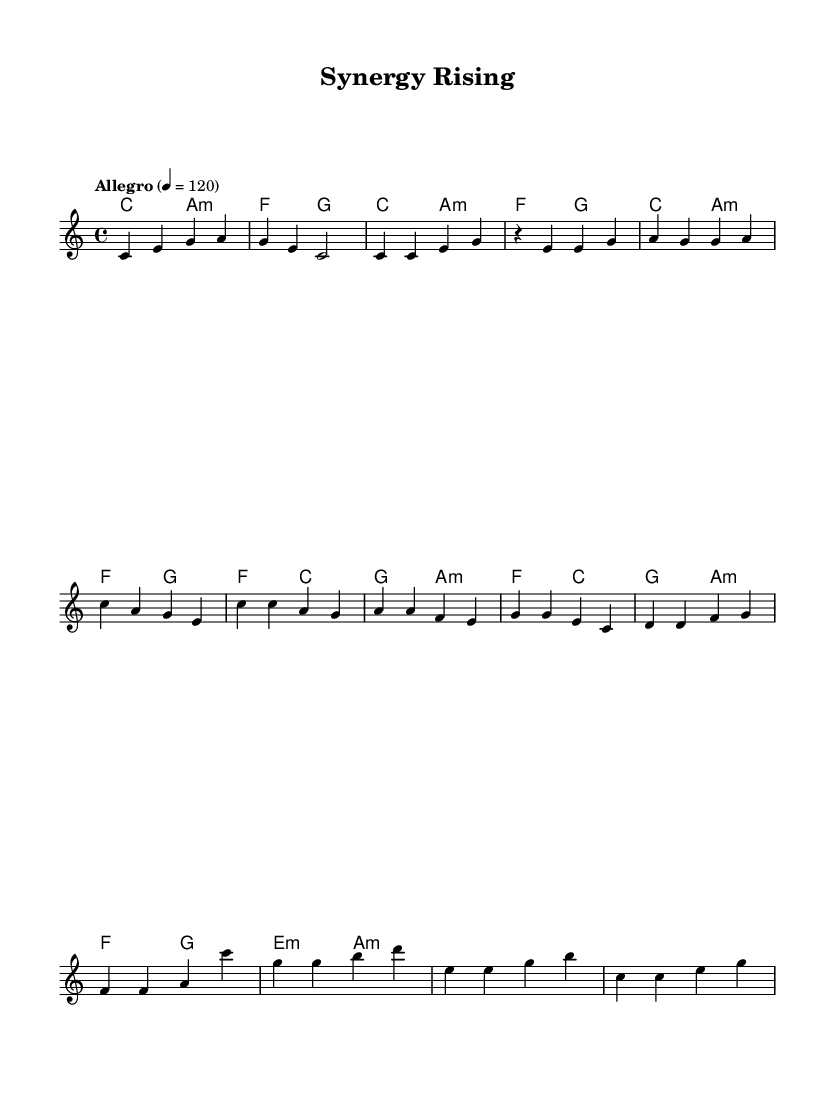What is the key signature of this music? The key signature indicated in the music is C major, which has no sharps or flats. It can be identified by looking at the beginning of the staff where the key signature is notated.
Answer: C major What is the time signature of this music? The time signature is 4/4, indicated at the beginning of the score. This means there are four beats in each measure and the quarter note receives one beat.
Answer: 4/4 What is the tempo marking of this piece? The tempo of the music is marked as "Allegro" at a speed of 120 beats per minute, which suggests a brisk pace and energy. This marking is found at the start of the piece.
Answer: Allegro 4 = 120 How many measures are in the melody section? By counting the measures from the beginning to the end of the melody separating them by bars, there are a total of 8 measures in the melody section.
Answer: 8 What chord is played in the chorus on the first beat of the first measure? The chord played on the first beat of the first measure of the chorus is C major, which is indicated in the chord notation within the score.
Answer: C Which harmony chord follows the second measure of the Verse? The harmony chord that follows the second measure of the verse is F major, as it is denoted in the chord changes after the first two measures of the verse.
Answer: F What is the last chord in the Bridge section? The last chord in the Bridge section is E minor, as shown in the chord notation that concludes this part of the score.
Answer: E minor 